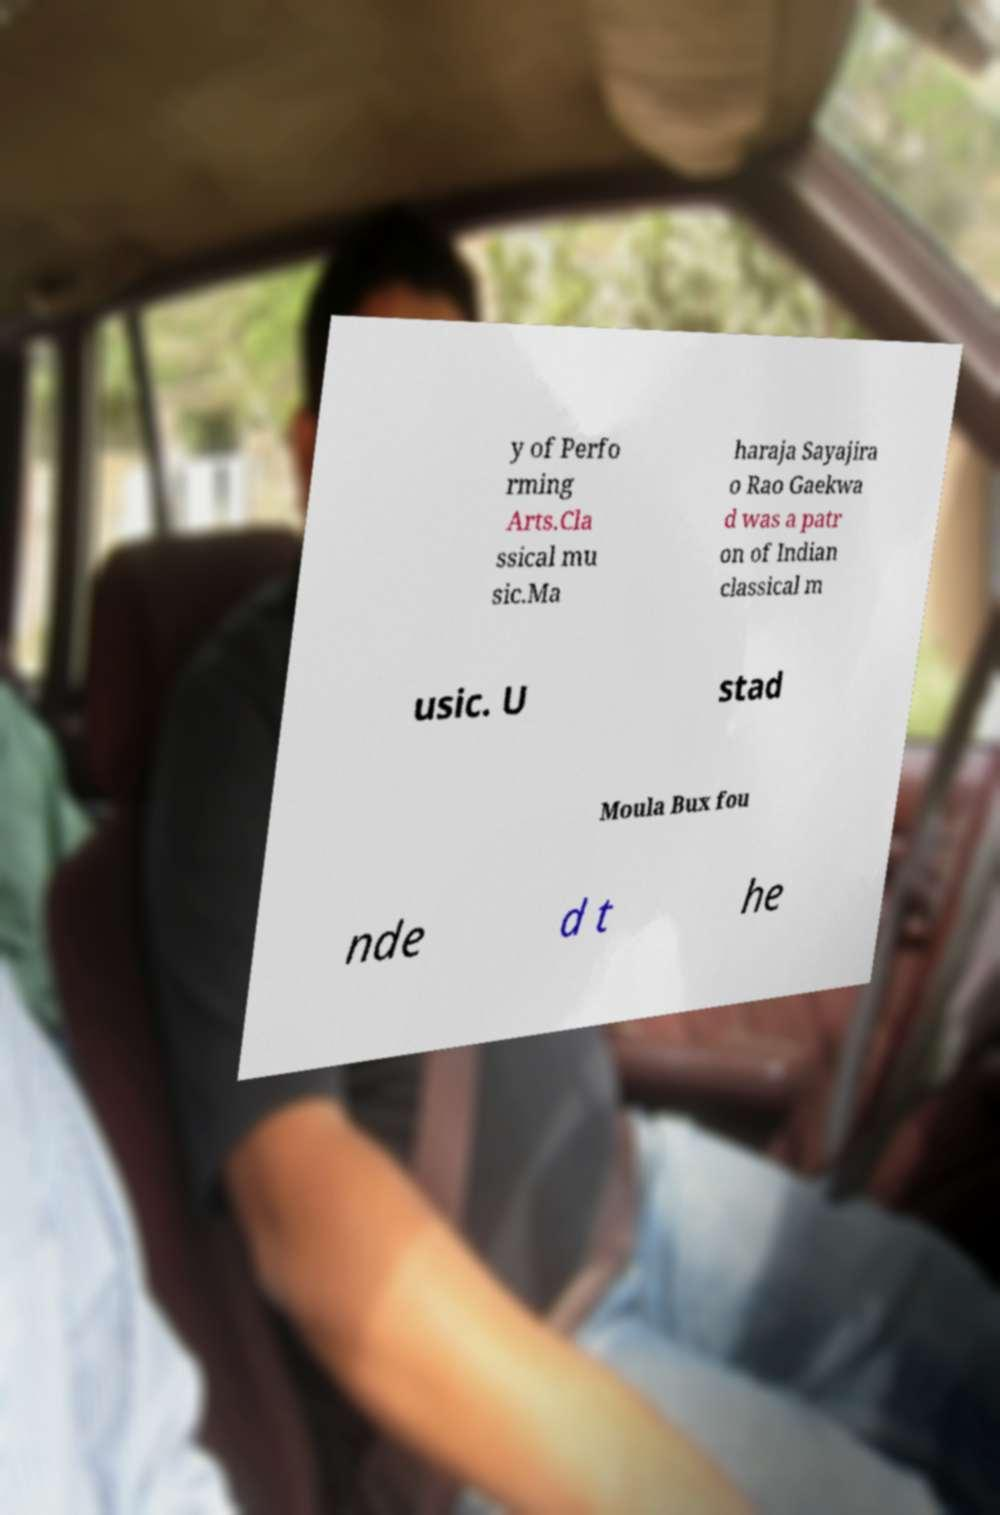Can you read and provide the text displayed in the image?This photo seems to have some interesting text. Can you extract and type it out for me? y of Perfo rming Arts.Cla ssical mu sic.Ma haraja Sayajira o Rao Gaekwa d was a patr on of Indian classical m usic. U stad Moula Bux fou nde d t he 